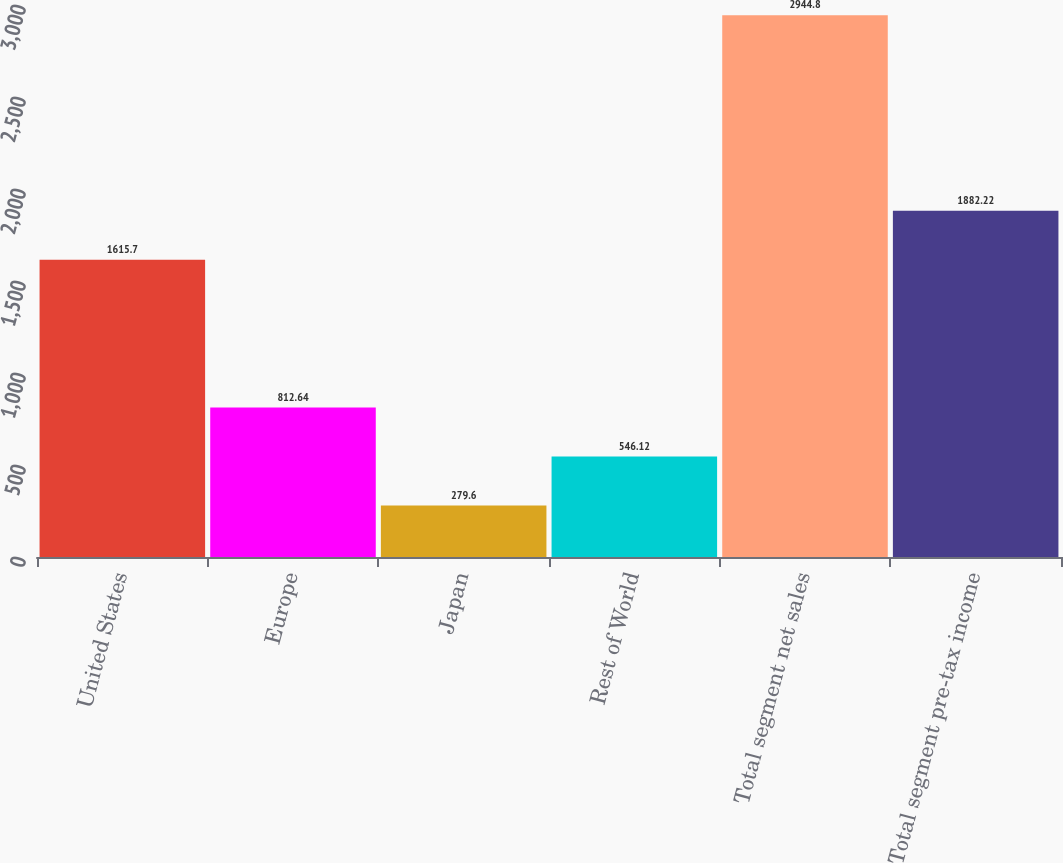<chart> <loc_0><loc_0><loc_500><loc_500><bar_chart><fcel>United States<fcel>Europe<fcel>Japan<fcel>Rest of World<fcel>Total segment net sales<fcel>Total segment pre-tax income<nl><fcel>1615.7<fcel>812.64<fcel>279.6<fcel>546.12<fcel>2944.8<fcel>1882.22<nl></chart> 